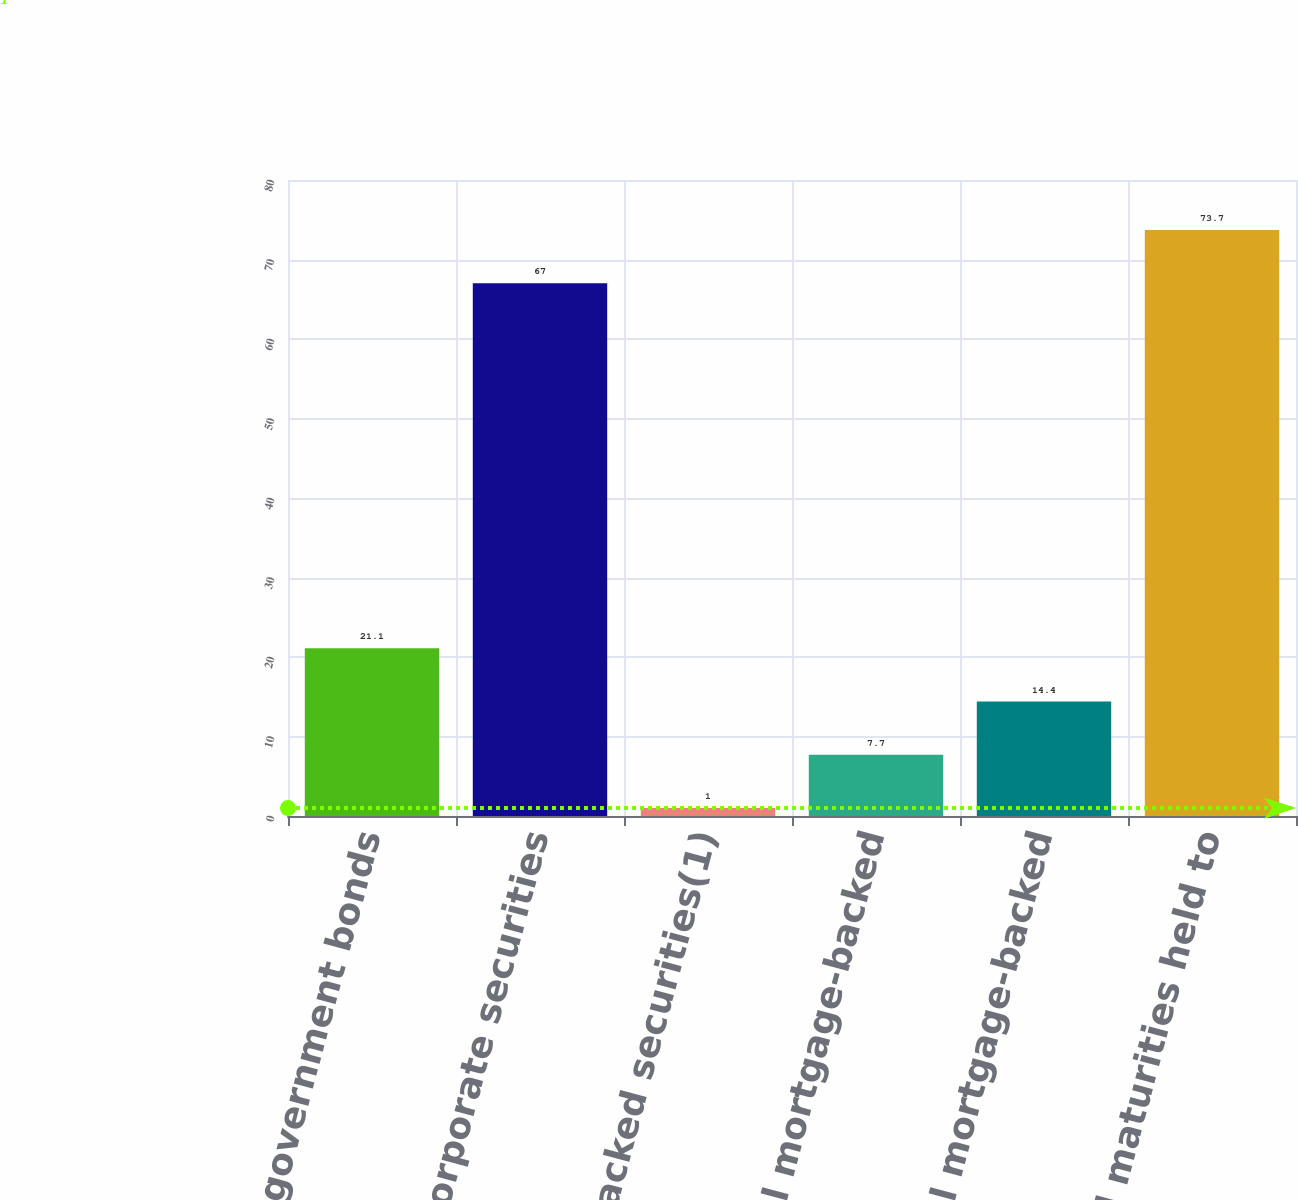Convert chart to OTSL. <chart><loc_0><loc_0><loc_500><loc_500><bar_chart><fcel>Foreign government bonds<fcel>Corporate securities<fcel>Asset-backed securities(1)<fcel>Commercial mortgage-backed<fcel>Residential mortgage-backed<fcel>Total fixed maturities held to<nl><fcel>21.1<fcel>67<fcel>1<fcel>7.7<fcel>14.4<fcel>73.7<nl></chart> 